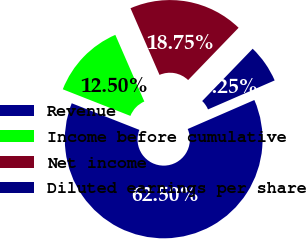<chart> <loc_0><loc_0><loc_500><loc_500><pie_chart><fcel>Revenue<fcel>Income before cumulative<fcel>Net income<fcel>Diluted earnings per share<nl><fcel>62.5%<fcel>12.5%<fcel>18.75%<fcel>6.25%<nl></chart> 